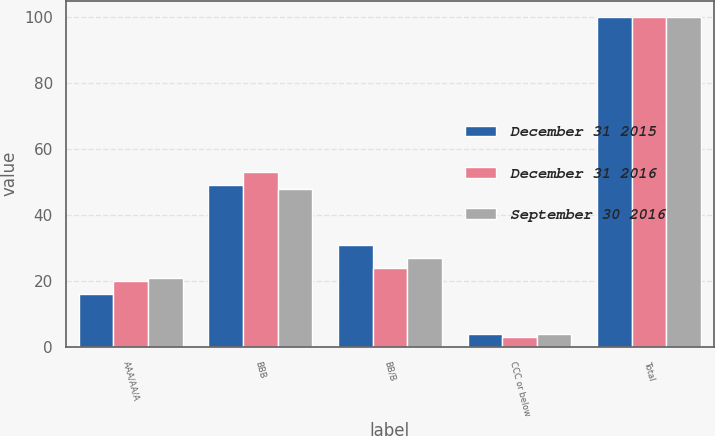<chart> <loc_0><loc_0><loc_500><loc_500><stacked_bar_chart><ecel><fcel>AAA/AA/A<fcel>BBB<fcel>BB/B<fcel>CCC or below<fcel>Total<nl><fcel>December 31 2015<fcel>16<fcel>49<fcel>31<fcel>4<fcel>100<nl><fcel>December 31 2016<fcel>20<fcel>53<fcel>24<fcel>3<fcel>100<nl><fcel>September 30 2016<fcel>21<fcel>48<fcel>27<fcel>4<fcel>100<nl></chart> 